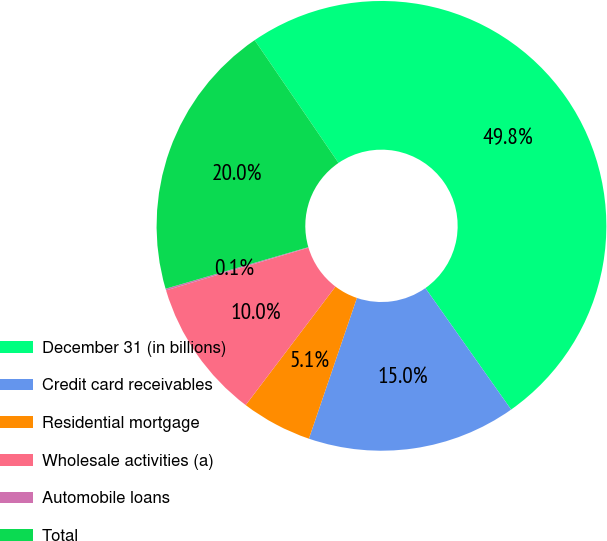Convert chart. <chart><loc_0><loc_0><loc_500><loc_500><pie_chart><fcel>December 31 (in billions)<fcel>Credit card receivables<fcel>Residential mortgage<fcel>Wholesale activities (a)<fcel>Automobile loans<fcel>Total<nl><fcel>49.76%<fcel>15.01%<fcel>5.09%<fcel>10.05%<fcel>0.12%<fcel>19.98%<nl></chart> 